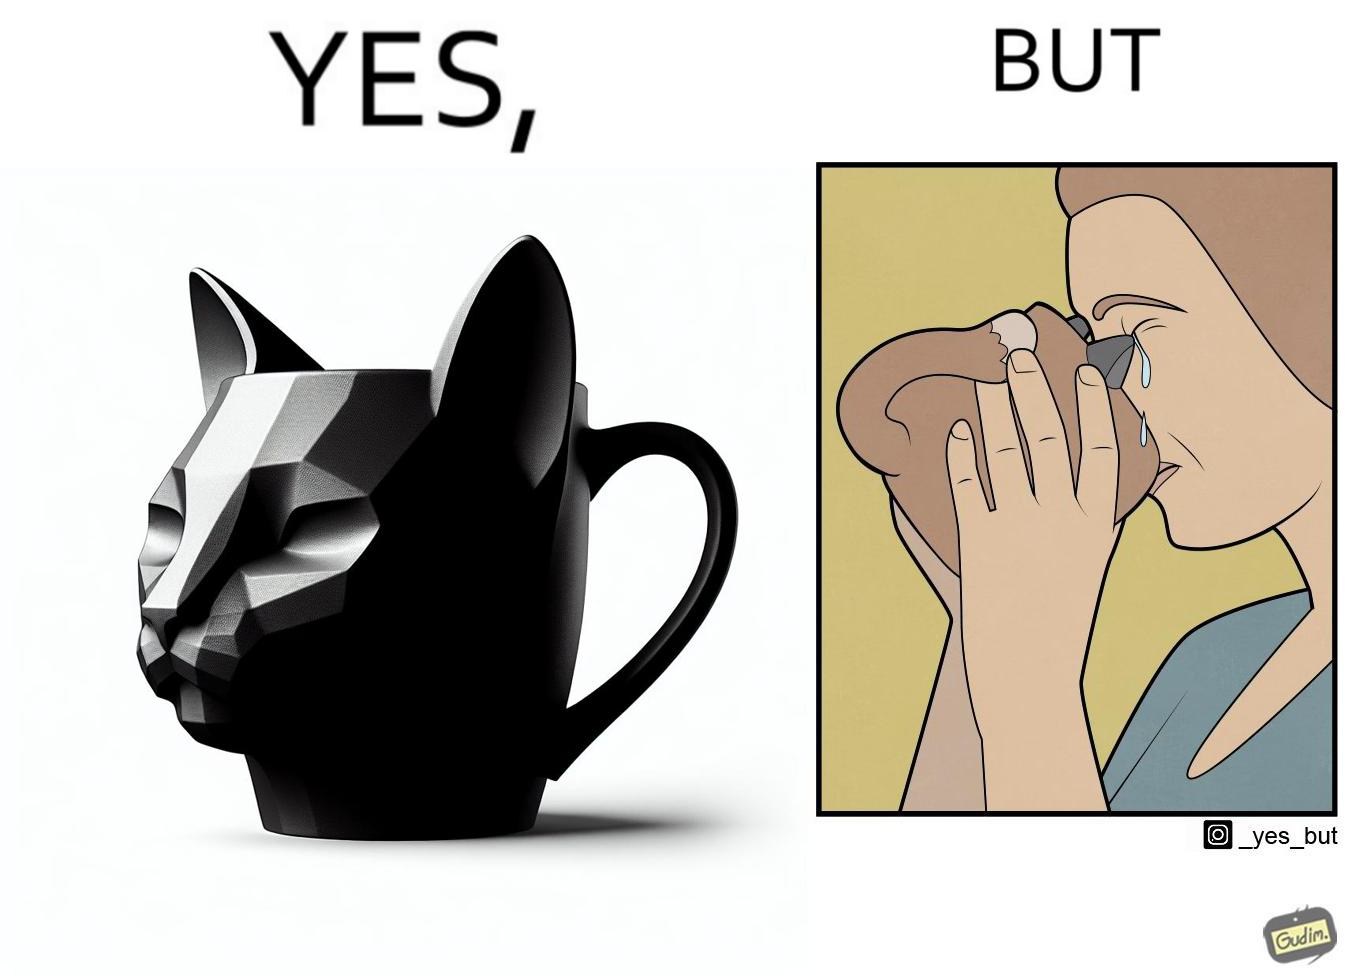What is shown in this image? The irony in the image is that the mug is supposedly cute and quirky but it is completely impractical as a mug as it will hurt its user. 